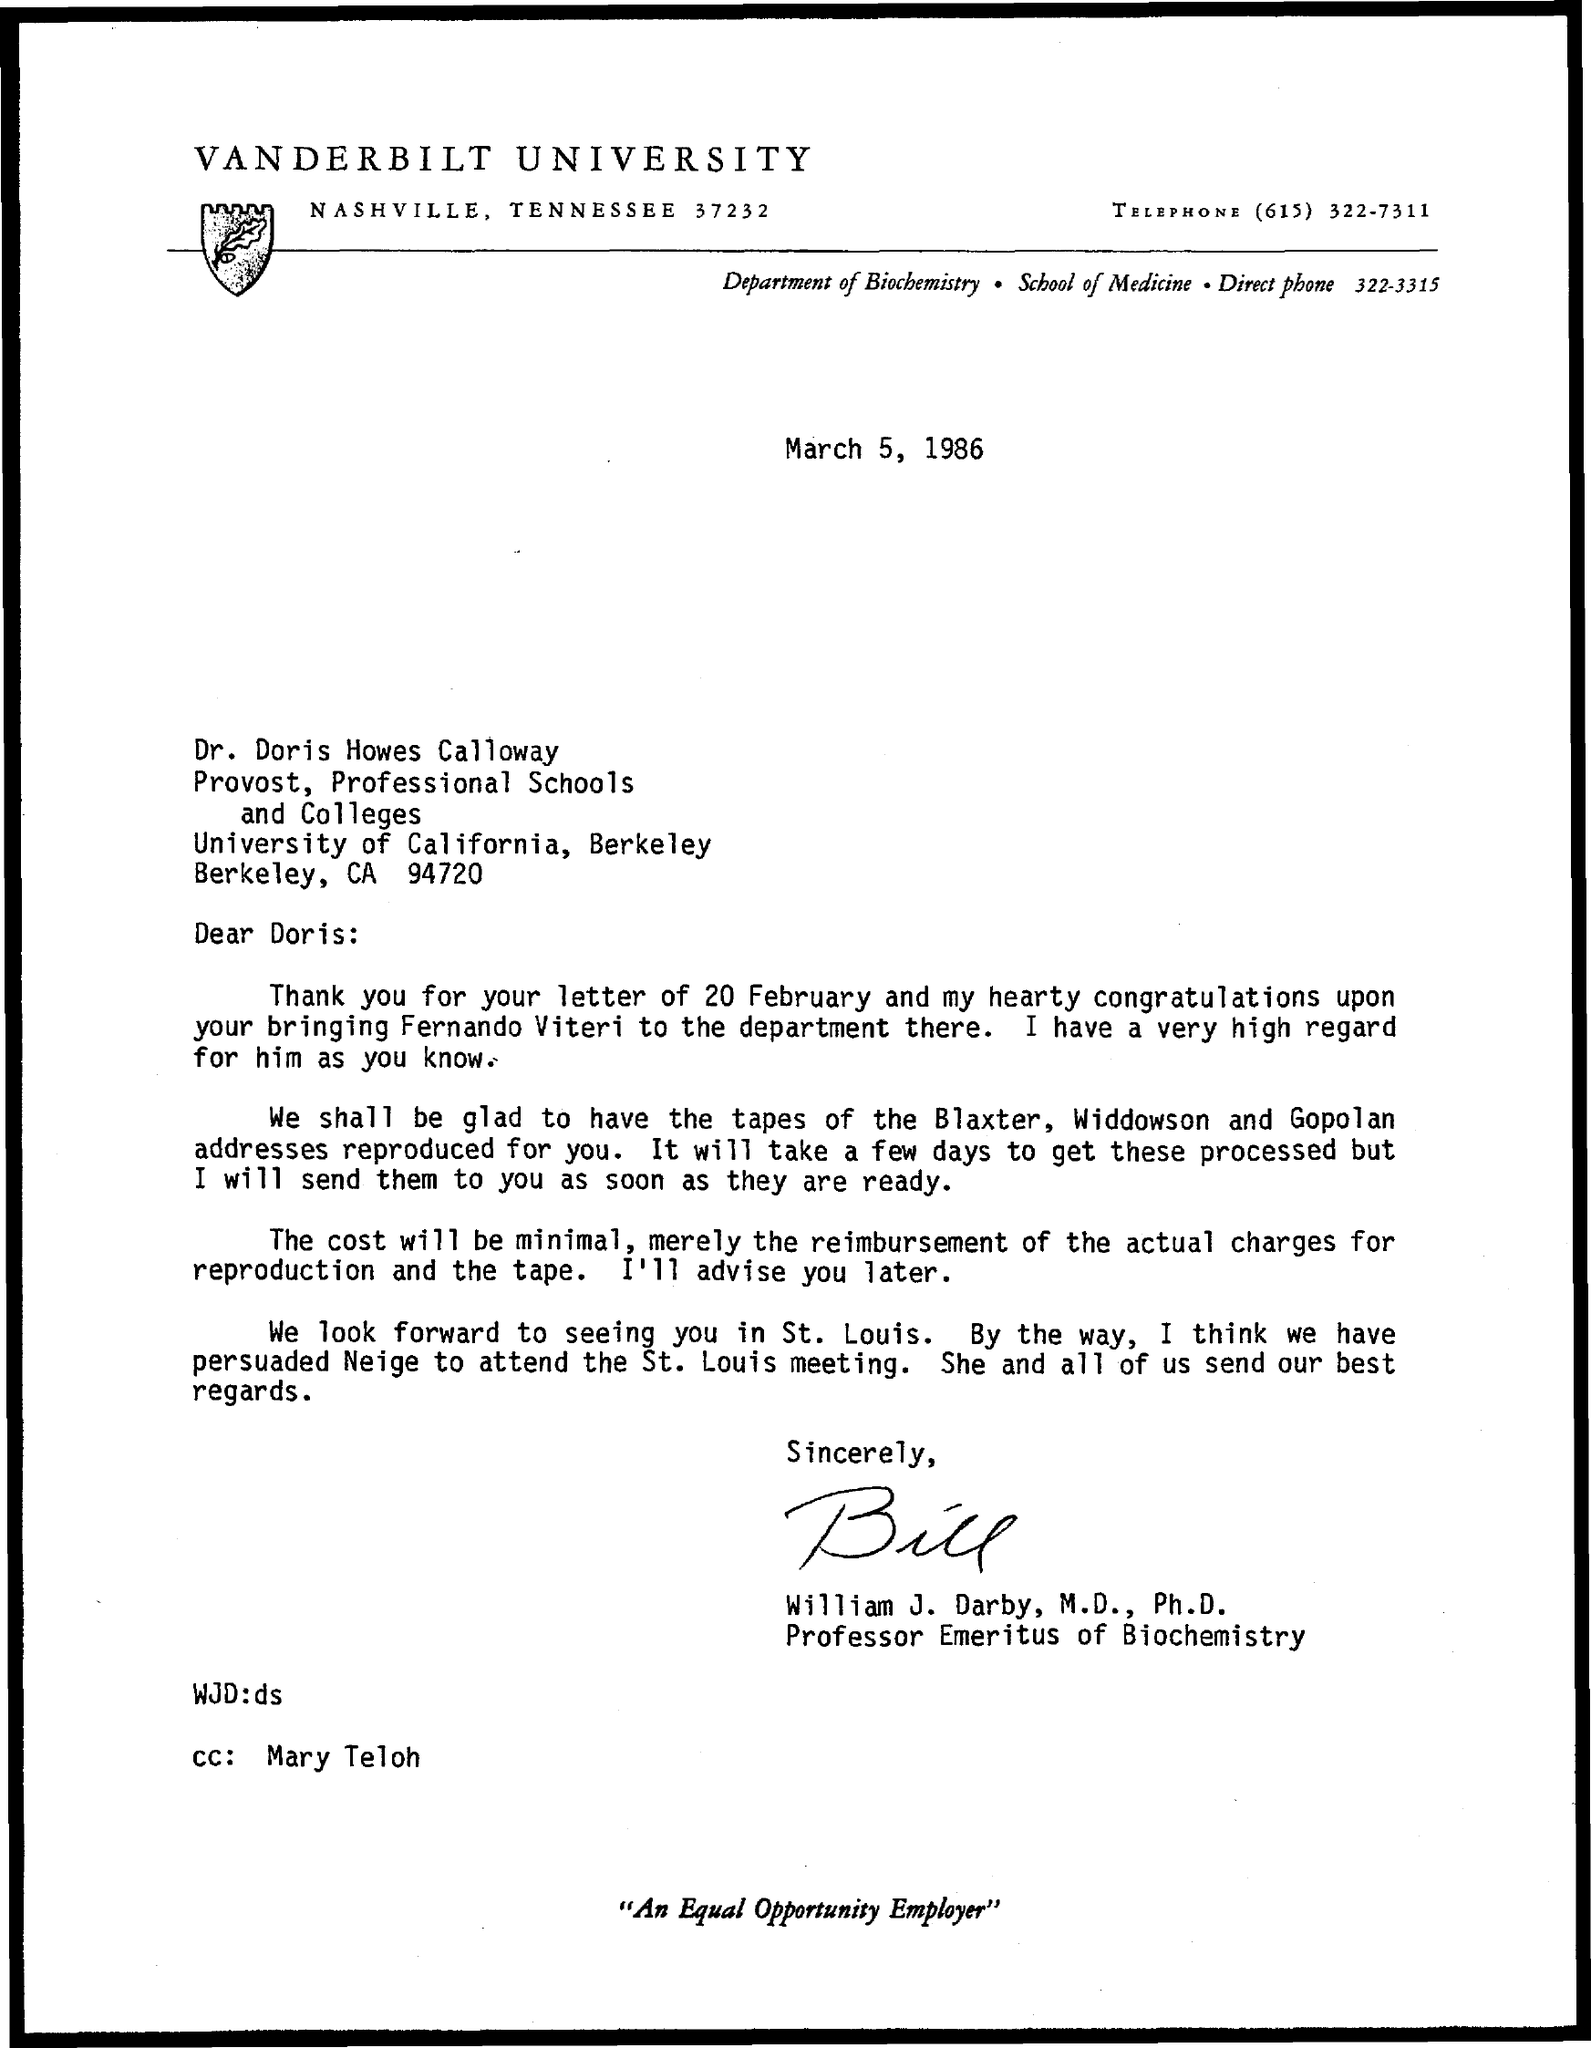What is the date mentioned in the given letter ?
Your response must be concise. March 5, 1986. What is the designation of william  j. darby ?
Your response must be concise. Professor Emeritus of Biochemistry. What is the name of the department mentioned in the given letter ?
Ensure brevity in your answer.  Department of biochemistry. What is the name of the university mentioned in the top of the letter ?
Your answer should be compact. Vanderbilt University. What is the telephone number mentioned in the given letter ?
Your response must be concise. (615) 322-7311. What is the direct phone number mentioned in the given letter ?
Make the answer very short. 322-3315. 